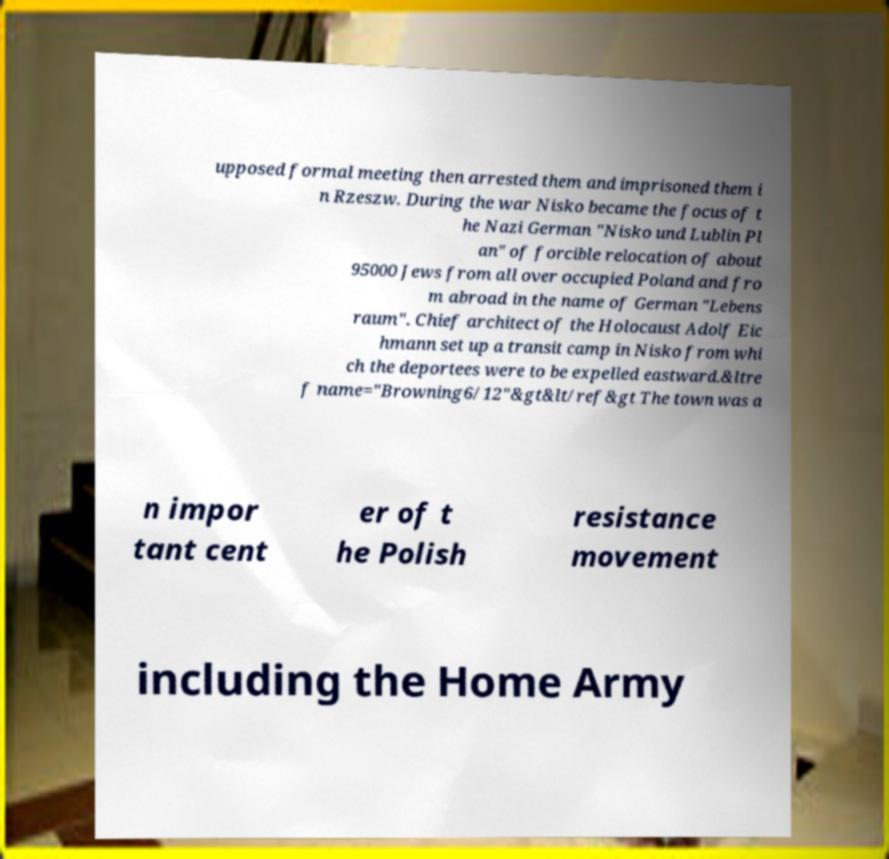There's text embedded in this image that I need extracted. Can you transcribe it verbatim? upposed formal meeting then arrested them and imprisoned them i n Rzeszw. During the war Nisko became the focus of t he Nazi German "Nisko und Lublin Pl an" of forcible relocation of about 95000 Jews from all over occupied Poland and fro m abroad in the name of German "Lebens raum". Chief architect of the Holocaust Adolf Eic hmann set up a transit camp in Nisko from whi ch the deportees were to be expelled eastward.&ltre f name="Browning6/12"&gt&lt/ref&gt The town was a n impor tant cent er of t he Polish resistance movement including the Home Army 